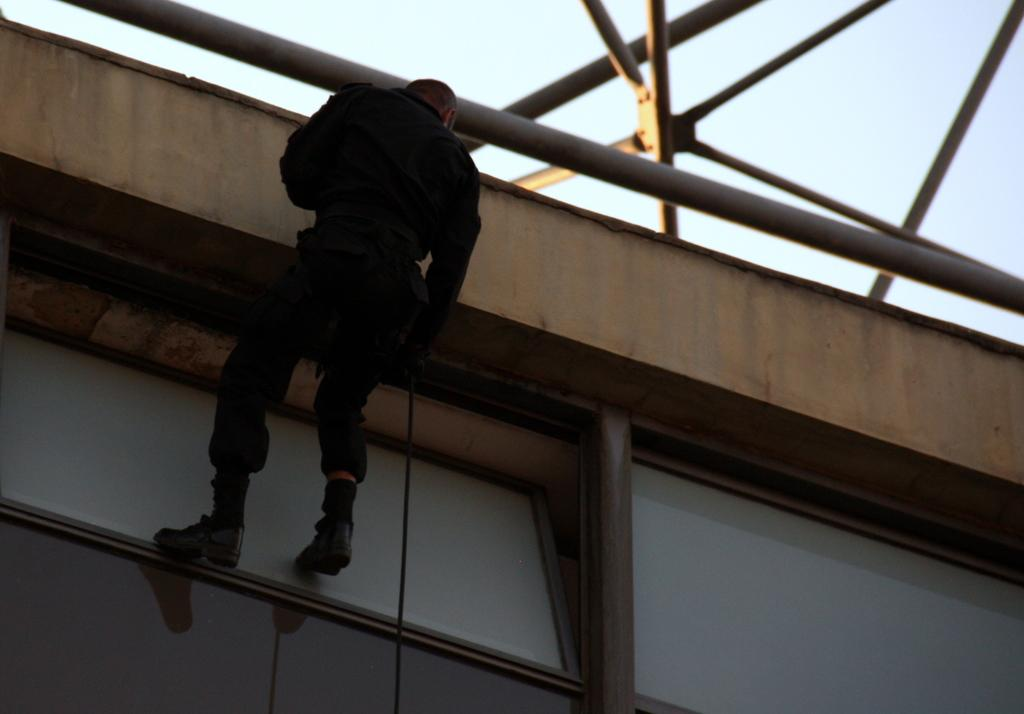What is the person in the image doing? The person is sitting on a pole in the image. What is the person wearing? The person is wearing a black dress. What can be seen in the background of the image? There are other poles visible in the background of the image. What is the color of the sky in the image? The sky is white in color. Are there any curtains hanging from the poles in the image? There is no mention of curtains in the image; only poles and a person sitting on one are visible. 